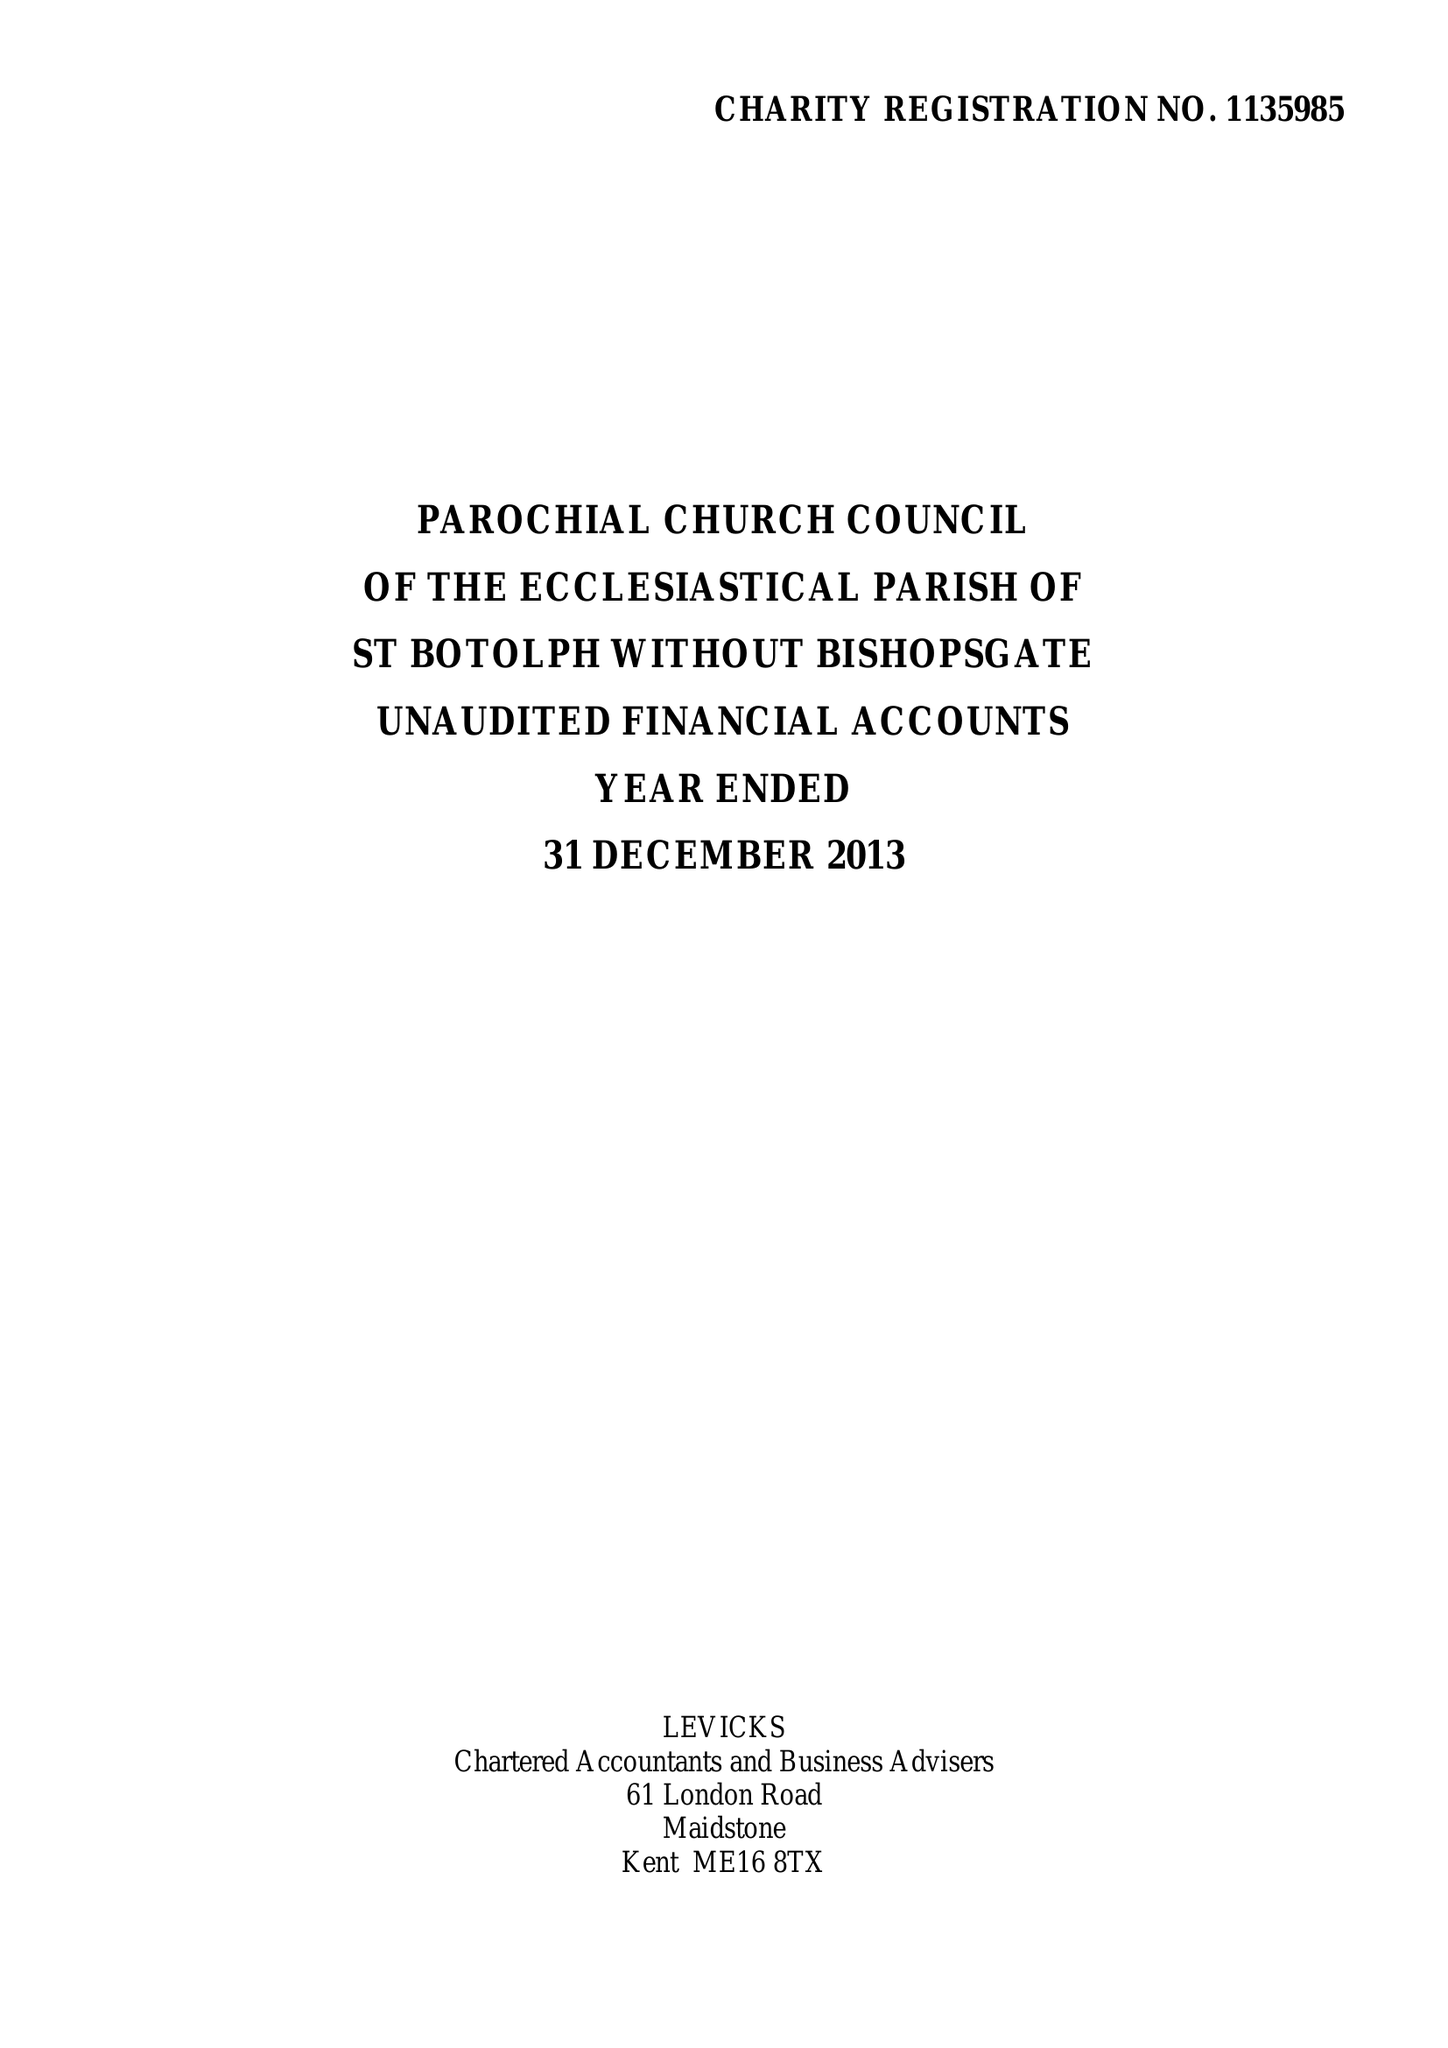What is the value for the address__street_line?
Answer the question using a single word or phrase. BISHOPSGATE 